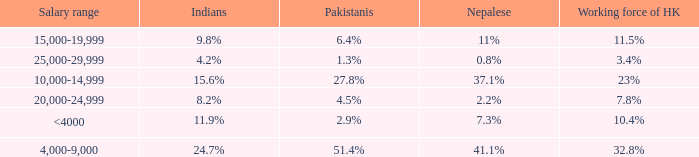If the nepalese is 37.1%, what is the working force of HK? 23%. 